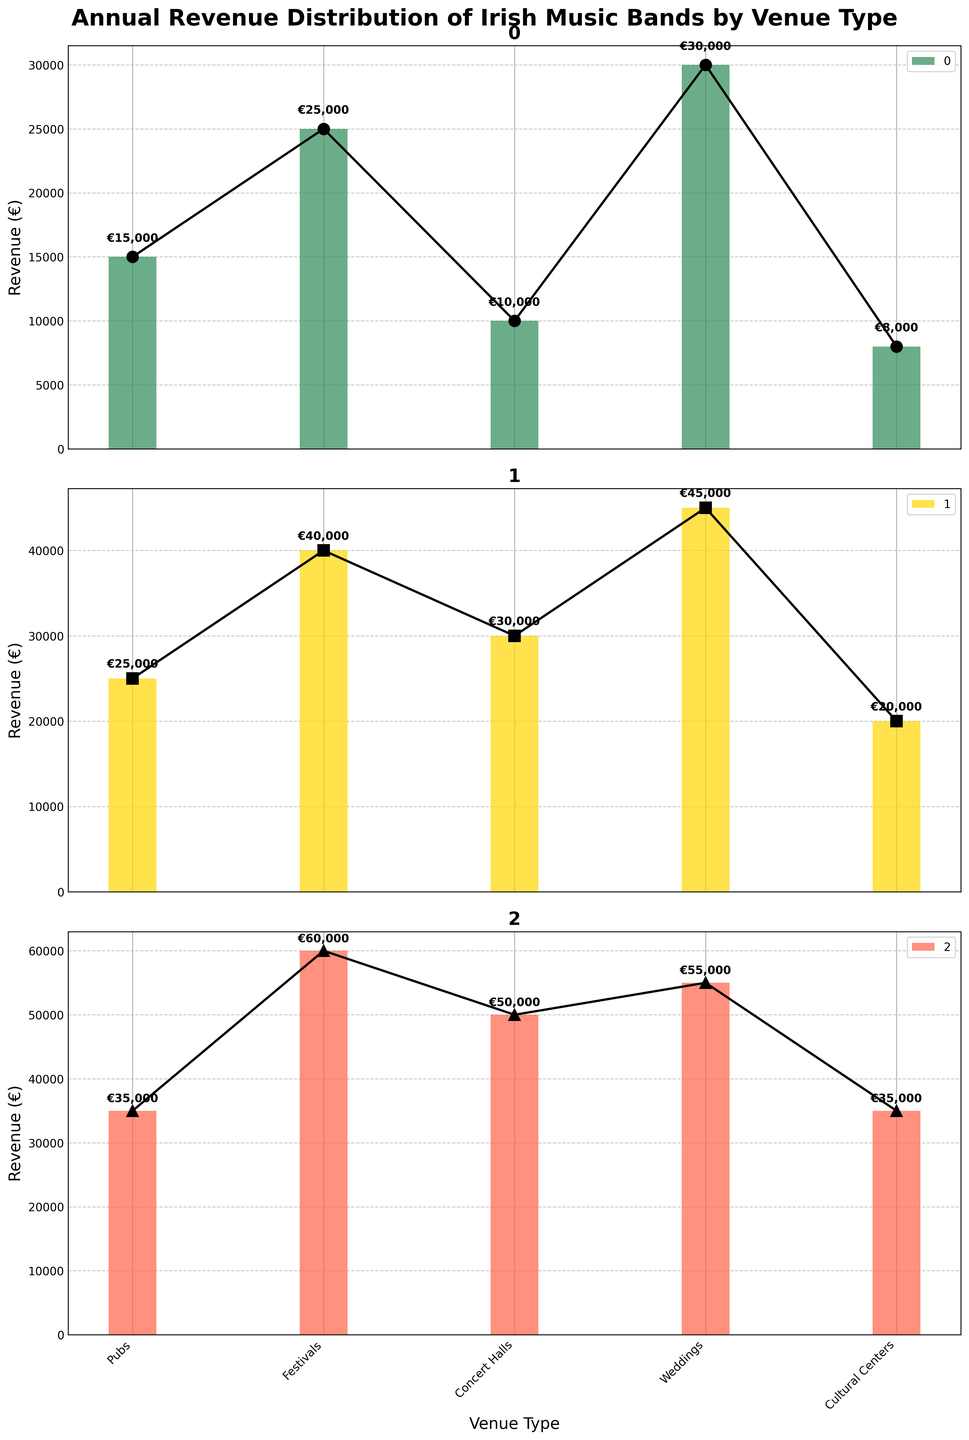What is the annual revenue for small bands performing at weddings? By observing the subplot for Small Bands, locate the bars representing each venue type. The bar representing Weddings is approximately €30,000.
Answer: €30,000 Compare the annual revenue of large bands performing in pubs versus cultural centers. Look at the subplot for Large Bands. The height of the bar for Pubs is approximately €35,000, whereas the bar for Cultural Centers is approximately €35,000.
Answer: Equal (€35,000) Which venue type generates the highest revenue for medium bands? In the subplot for Medium Bands, compare the heights of the bars representing different venue types. The highest bar corresponds to Festivals, with a value of €40,000.
Answer: Festivals (€40,000) Summarize the total annual revenue for small bands across all venue types. To get the total revenue, sum up the values in the Small Bands subplot: €15,000 + €25,000 + €10,000 + €30,000 + €8,000. Total = €88,000.
Answer: €88,000 Do medium bands earn more from festivals or concert halls, and by how much? In the subplot for Medium Bands, the revenue from Festivals is €40,000, and from Concert Halls is €30,000. The difference is €40,000 - €30,000 = €10,000.
Answer: Festivals, by €10,000 Which type of band earns more at cultural centers, small or medium bands? Check the subplots for Small Bands and Medium Bands. The revenue for Small Bands at Cultural Centers is €8,000, whereas for Medium Bands it is €20,000. Therefore, Medium Bands earn more.
Answer: Medium Bands (€20,000) What is the average annual revenue for large bands across all venues? Add up the revenues for Large Bands across each venue: €35,000 + €60,000 + €50,000 + €55,000 + €35,000. The total is €235,000. Dividing by the 5 venues gives us an average of €235,000 / 5 = €47,000.
Answer: €47,000 Compare the revenues of the three bands for concert halls and identify the largest discrepancy. Small Bands earn €10,000, Medium Bands earn €30,000, and Large Bands earn €50,000 from Concert Halls. The largest discrepancy is between Small Bands and Large Bands, with a difference of €50,000 - €10,000 = €40,000.
Answer: €40,000 